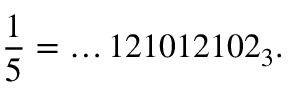<formula> <loc_0><loc_0><loc_500><loc_500>{ \frac { 1 } { 5 } } = \dots 1 2 1 0 1 2 1 0 2 _ { 3 } .</formula> 